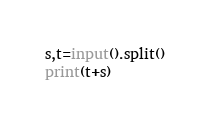Convert code to text. <code><loc_0><loc_0><loc_500><loc_500><_Python_>s,t=input().split()
print(t+s)
</code> 